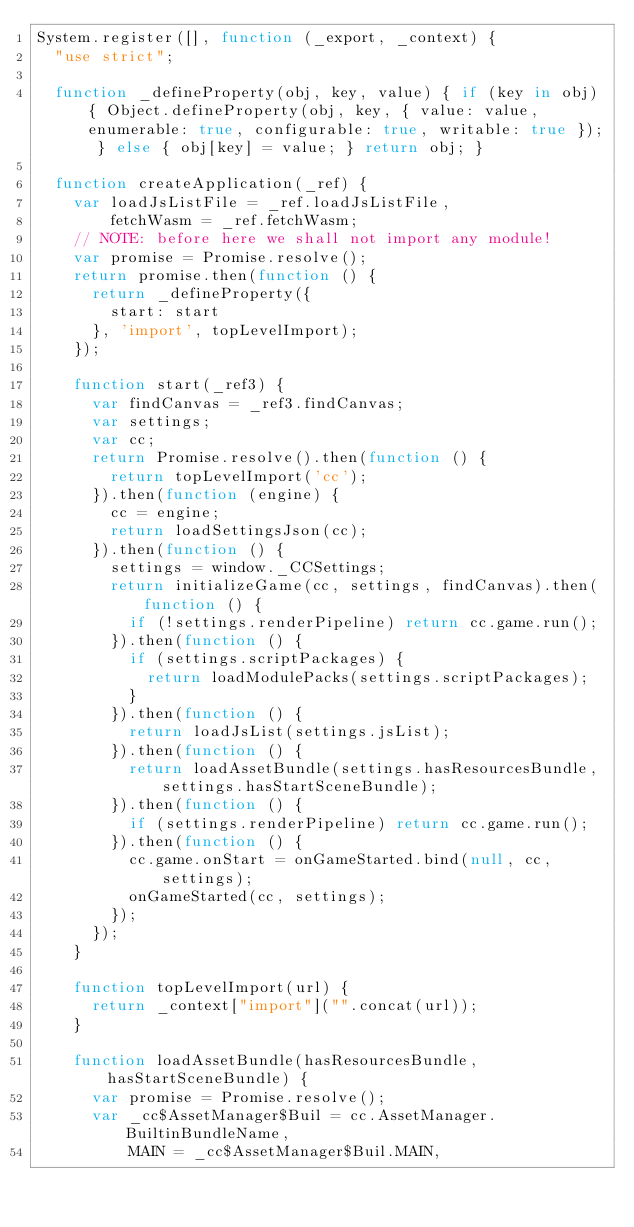<code> <loc_0><loc_0><loc_500><loc_500><_JavaScript_>System.register([], function (_export, _context) {
  "use strict";

  function _defineProperty(obj, key, value) { if (key in obj) { Object.defineProperty(obj, key, { value: value, enumerable: true, configurable: true, writable: true }); } else { obj[key] = value; } return obj; }

  function createApplication(_ref) {
    var loadJsListFile = _ref.loadJsListFile,
        fetchWasm = _ref.fetchWasm;
    // NOTE: before here we shall not import any module!
    var promise = Promise.resolve();
    return promise.then(function () {
      return _defineProperty({
        start: start
      }, 'import', topLevelImport);
    });

    function start(_ref3) {
      var findCanvas = _ref3.findCanvas;
      var settings;
      var cc;
      return Promise.resolve().then(function () {
        return topLevelImport('cc');
      }).then(function (engine) {
        cc = engine;
        return loadSettingsJson(cc);
      }).then(function () {
        settings = window._CCSettings;
        return initializeGame(cc, settings, findCanvas).then(function () {
          if (!settings.renderPipeline) return cc.game.run();
        }).then(function () {
          if (settings.scriptPackages) {
            return loadModulePacks(settings.scriptPackages);
          }
        }).then(function () {
          return loadJsList(settings.jsList);
        }).then(function () {
          return loadAssetBundle(settings.hasResourcesBundle, settings.hasStartSceneBundle);
        }).then(function () {
          if (settings.renderPipeline) return cc.game.run();
        }).then(function () {
          cc.game.onStart = onGameStarted.bind(null, cc, settings);
          onGameStarted(cc, settings);
        });
      });
    }

    function topLevelImport(url) {
      return _context["import"]("".concat(url));
    }

    function loadAssetBundle(hasResourcesBundle, hasStartSceneBundle) {
      var promise = Promise.resolve();
      var _cc$AssetManager$Buil = cc.AssetManager.BuiltinBundleName,
          MAIN = _cc$AssetManager$Buil.MAIN,</code> 